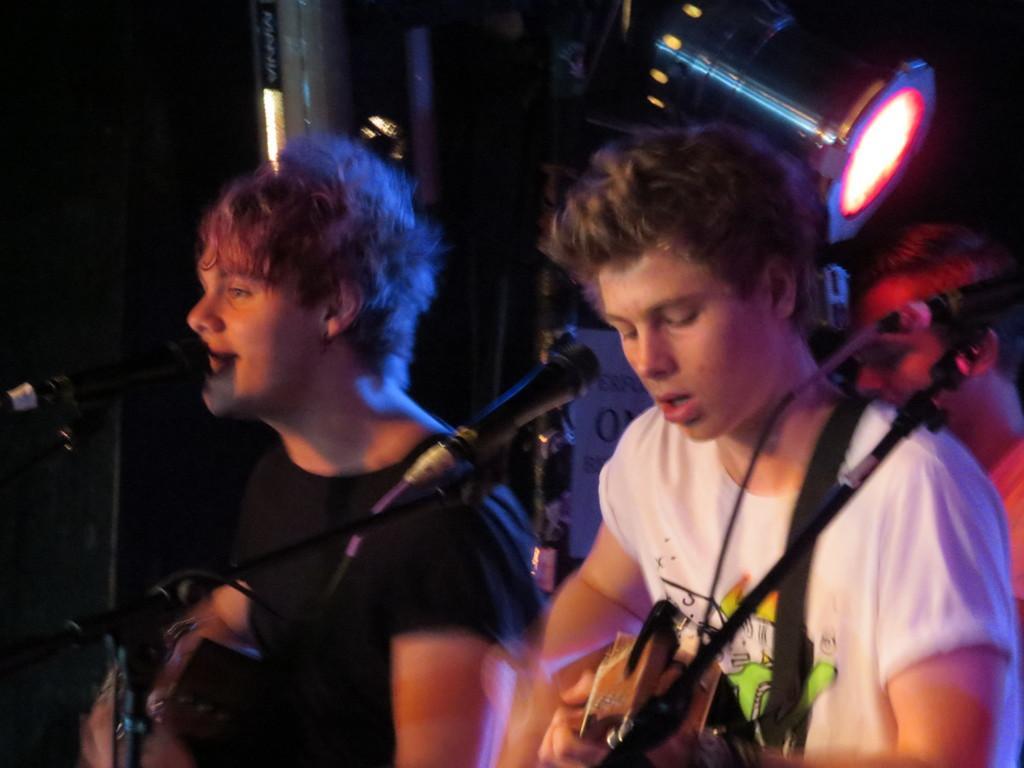How would you summarize this image in a sentence or two? There are 3 people hear singing and performing by playing musical instruments. Behind them there is a light. 